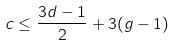Convert formula to latex. <formula><loc_0><loc_0><loc_500><loc_500>c \leq \frac { 3 d - 1 } { 2 } + 3 ( g - 1 )</formula> 